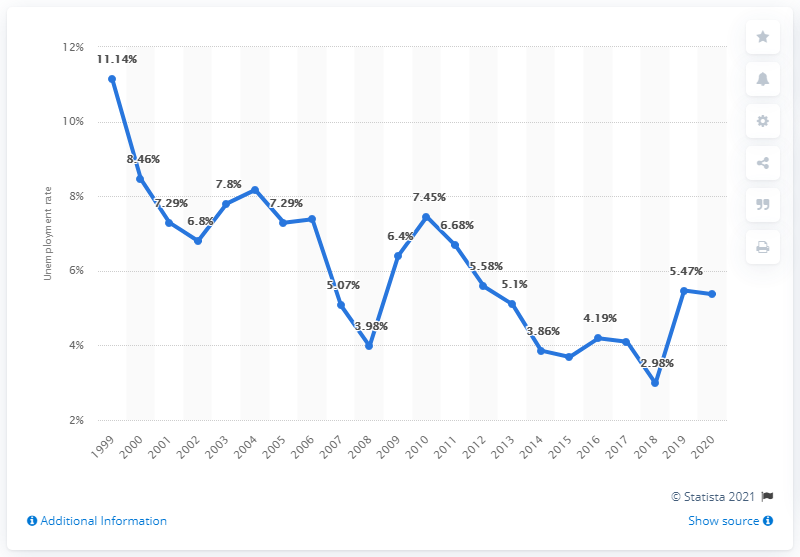Identify some key points in this picture. The unemployment rate in Moldova in 2020 was 5.37%. 